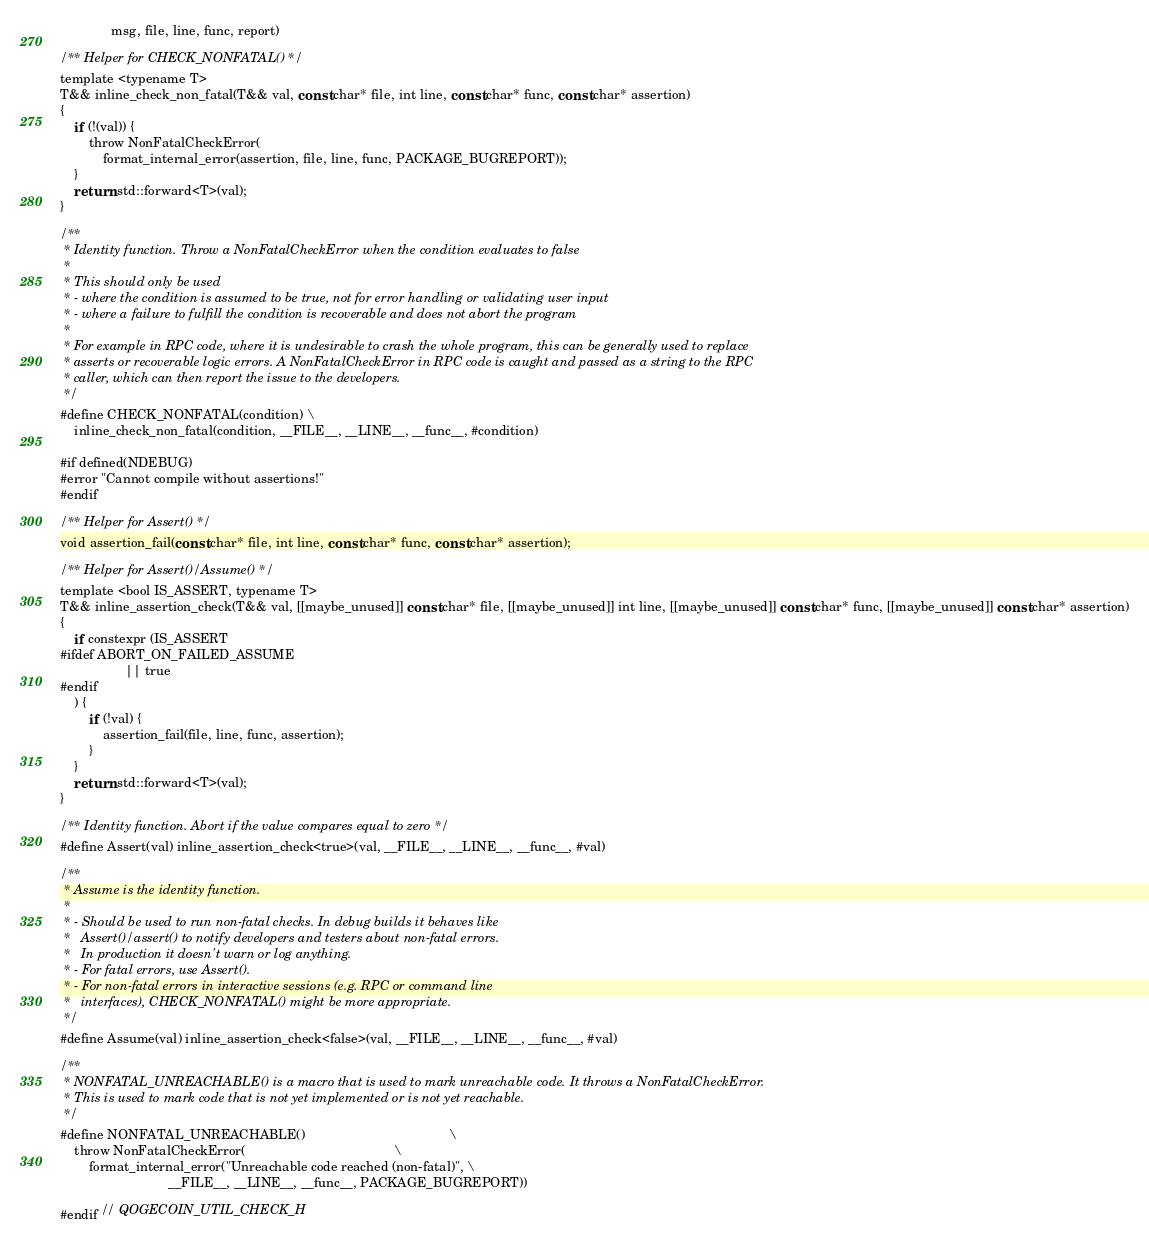Convert code to text. <code><loc_0><loc_0><loc_500><loc_500><_C_>              msg, file, line, func, report)

/** Helper for CHECK_NONFATAL() */
template <typename T>
T&& inline_check_non_fatal(T&& val, const char* file, int line, const char* func, const char* assertion)
{
    if (!(val)) {
        throw NonFatalCheckError(
            format_internal_error(assertion, file, line, func, PACKAGE_BUGREPORT));
    }
    return std::forward<T>(val);
}

/**
 * Identity function. Throw a NonFatalCheckError when the condition evaluates to false
 *
 * This should only be used
 * - where the condition is assumed to be true, not for error handling or validating user input
 * - where a failure to fulfill the condition is recoverable and does not abort the program
 *
 * For example in RPC code, where it is undesirable to crash the whole program, this can be generally used to replace
 * asserts or recoverable logic errors. A NonFatalCheckError in RPC code is caught and passed as a string to the RPC
 * caller, which can then report the issue to the developers.
 */
#define CHECK_NONFATAL(condition) \
    inline_check_non_fatal(condition, __FILE__, __LINE__, __func__, #condition)

#if defined(NDEBUG)
#error "Cannot compile without assertions!"
#endif

/** Helper for Assert() */
void assertion_fail(const char* file, int line, const char* func, const char* assertion);

/** Helper for Assert()/Assume() */
template <bool IS_ASSERT, typename T>
T&& inline_assertion_check(T&& val, [[maybe_unused]] const char* file, [[maybe_unused]] int line, [[maybe_unused]] const char* func, [[maybe_unused]] const char* assertion)
{
    if constexpr (IS_ASSERT
#ifdef ABORT_ON_FAILED_ASSUME
                  || true
#endif
    ) {
        if (!val) {
            assertion_fail(file, line, func, assertion);
        }
    }
    return std::forward<T>(val);
}

/** Identity function. Abort if the value compares equal to zero */
#define Assert(val) inline_assertion_check<true>(val, __FILE__, __LINE__, __func__, #val)

/**
 * Assume is the identity function.
 *
 * - Should be used to run non-fatal checks. In debug builds it behaves like
 *   Assert()/assert() to notify developers and testers about non-fatal errors.
 *   In production it doesn't warn or log anything.
 * - For fatal errors, use Assert().
 * - For non-fatal errors in interactive sessions (e.g. RPC or command line
 *   interfaces), CHECK_NONFATAL() might be more appropriate.
 */
#define Assume(val) inline_assertion_check<false>(val, __FILE__, __LINE__, __func__, #val)

/**
 * NONFATAL_UNREACHABLE() is a macro that is used to mark unreachable code. It throws a NonFatalCheckError.
 * This is used to mark code that is not yet implemented or is not yet reachable.
 */
#define NONFATAL_UNREACHABLE()                                        \
    throw NonFatalCheckError(                                         \
        format_internal_error("Unreachable code reached (non-fatal)", \
                              __FILE__, __LINE__, __func__, PACKAGE_BUGREPORT))

#endif // QOGECOIN_UTIL_CHECK_H
</code> 